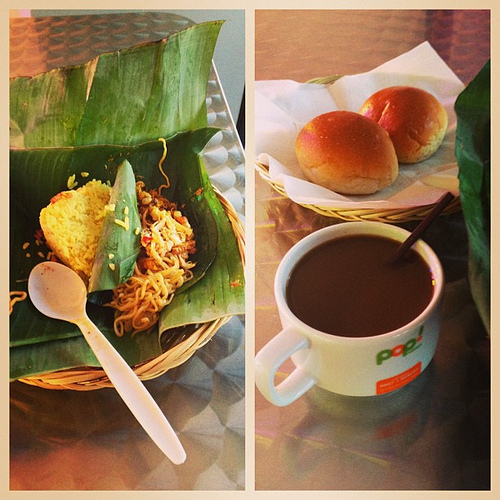What drink is to the right of the spoon? Adjacent to the spoon, on the right, is a mug of coffee, its steam subtly rising, hinting at a freshly brewed concoction. 